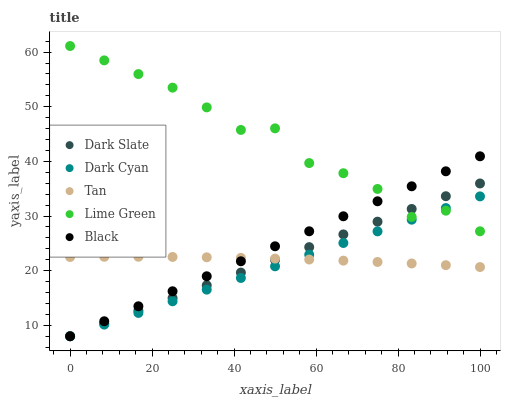Does Dark Cyan have the minimum area under the curve?
Answer yes or no. Yes. Does Lime Green have the maximum area under the curve?
Answer yes or no. Yes. Does Dark Slate have the minimum area under the curve?
Answer yes or no. No. Does Dark Slate have the maximum area under the curve?
Answer yes or no. No. Is Dark Cyan the smoothest?
Answer yes or no. Yes. Is Lime Green the roughest?
Answer yes or no. Yes. Is Dark Slate the smoothest?
Answer yes or no. No. Is Dark Slate the roughest?
Answer yes or no. No. Does Dark Cyan have the lowest value?
Answer yes or no. Yes. Does Tan have the lowest value?
Answer yes or no. No. Does Lime Green have the highest value?
Answer yes or no. Yes. Does Dark Slate have the highest value?
Answer yes or no. No. Is Tan less than Lime Green?
Answer yes or no. Yes. Is Lime Green greater than Tan?
Answer yes or no. Yes. Does Dark Cyan intersect Black?
Answer yes or no. Yes. Is Dark Cyan less than Black?
Answer yes or no. No. Is Dark Cyan greater than Black?
Answer yes or no. No. Does Tan intersect Lime Green?
Answer yes or no. No. 